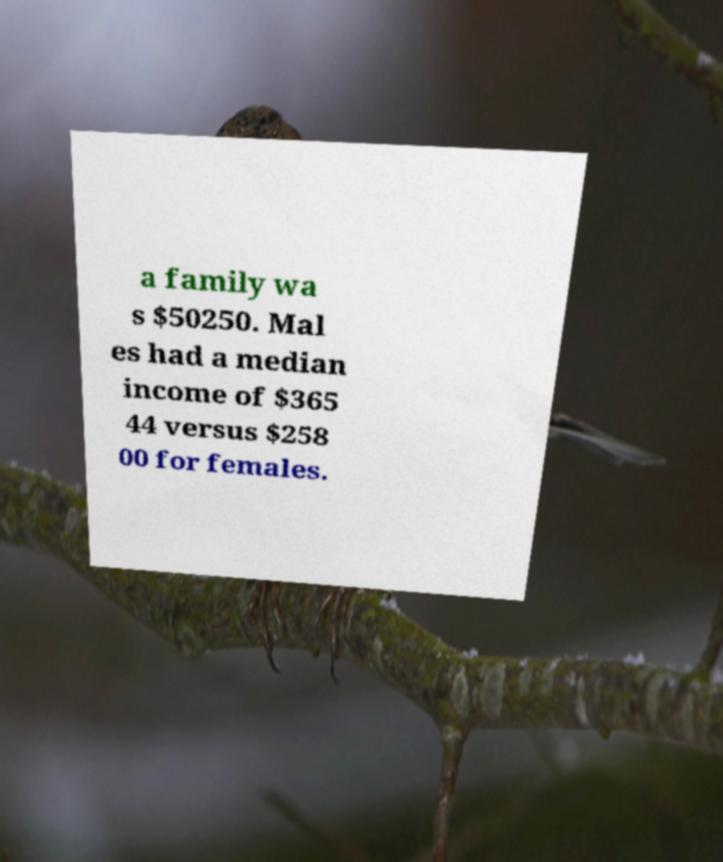I need the written content from this picture converted into text. Can you do that? a family wa s $50250. Mal es had a median income of $365 44 versus $258 00 for females. 